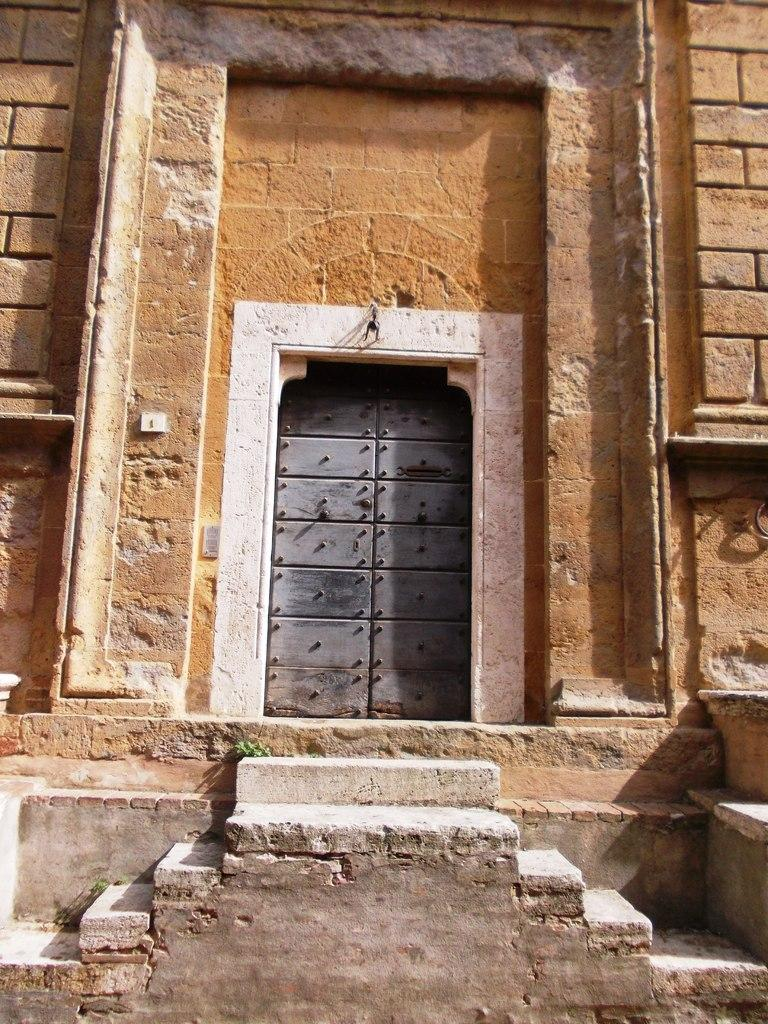What type of structure can be seen in the image? There is a door in the image. What is the color of the door? The door is grey in color. What architectural feature is present in the image? There are steps in the image. What is the color of the steps? The steps are in brown color. What else can be seen in the image besides the door and steps? There is a wall in the image. What is the color of the wall? The wall is in brown color. Where is the stove located in the image? There is no stove present in the image. What type of seat can be seen in the image? There is no seat present in the image. 